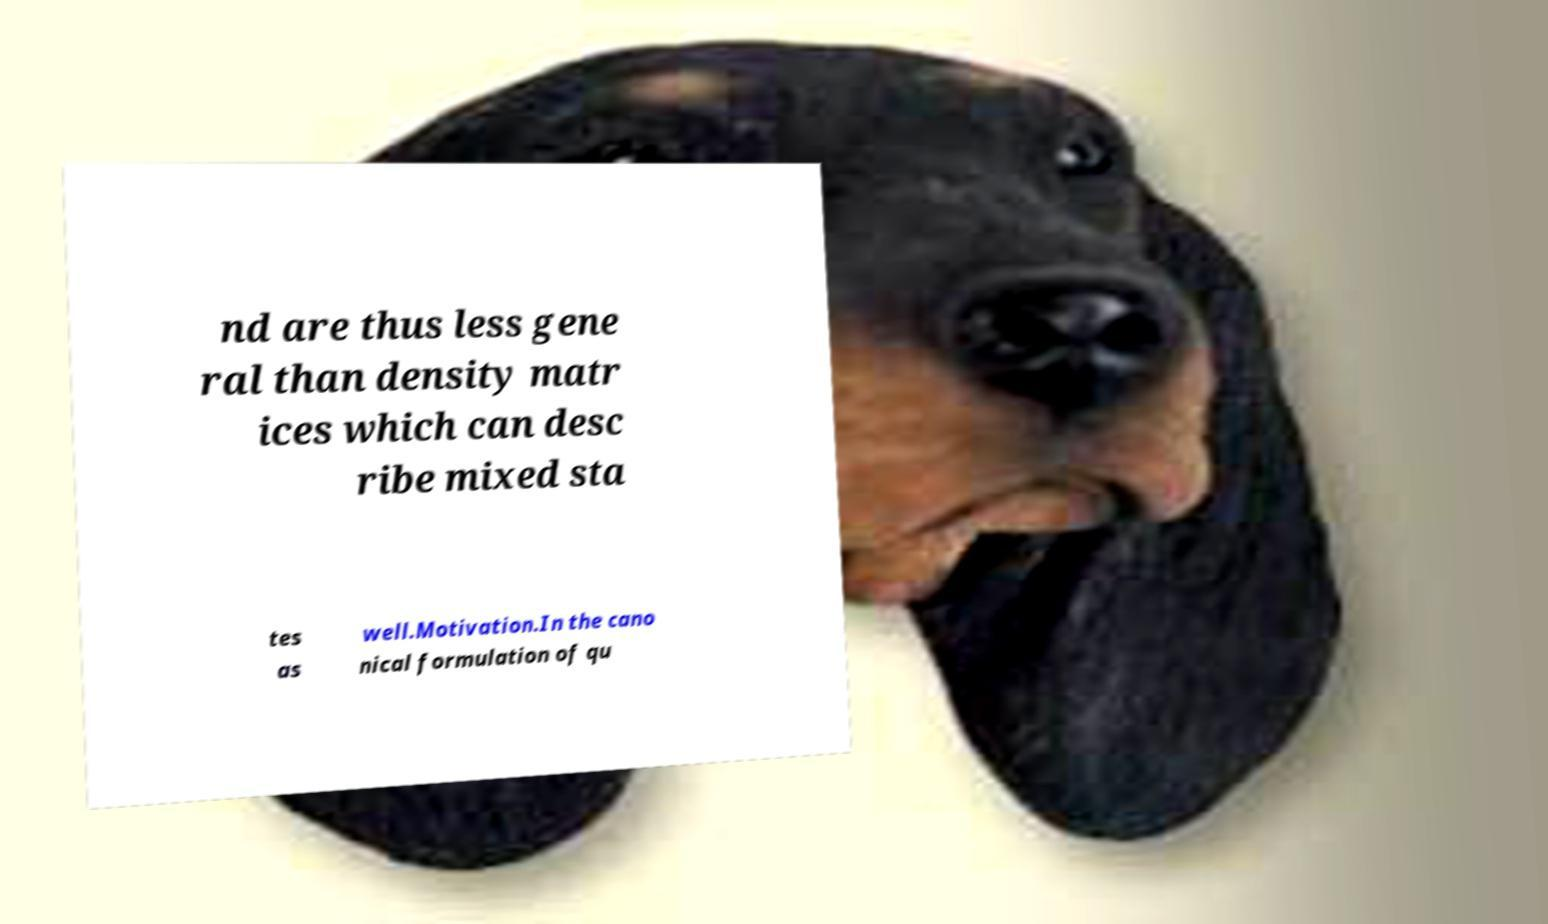Can you accurately transcribe the text from the provided image for me? nd are thus less gene ral than density matr ices which can desc ribe mixed sta tes as well.Motivation.In the cano nical formulation of qu 